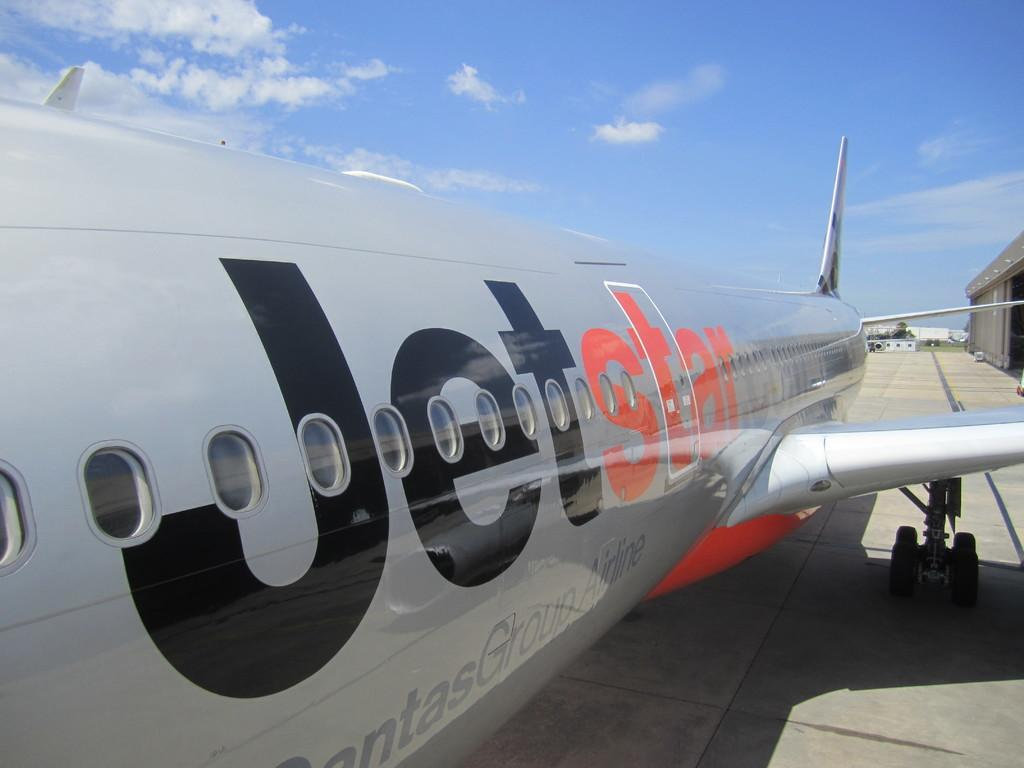<image>
Present a compact description of the photo's key features. a silver jet with the letters Jet in black and star in red. 